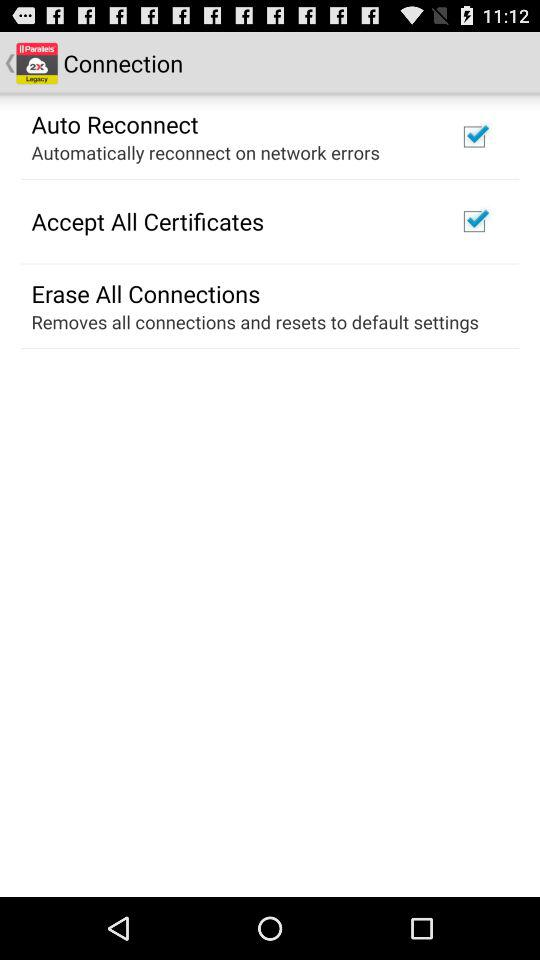What is the status of "Auto Reconnect"? The status is "on". 